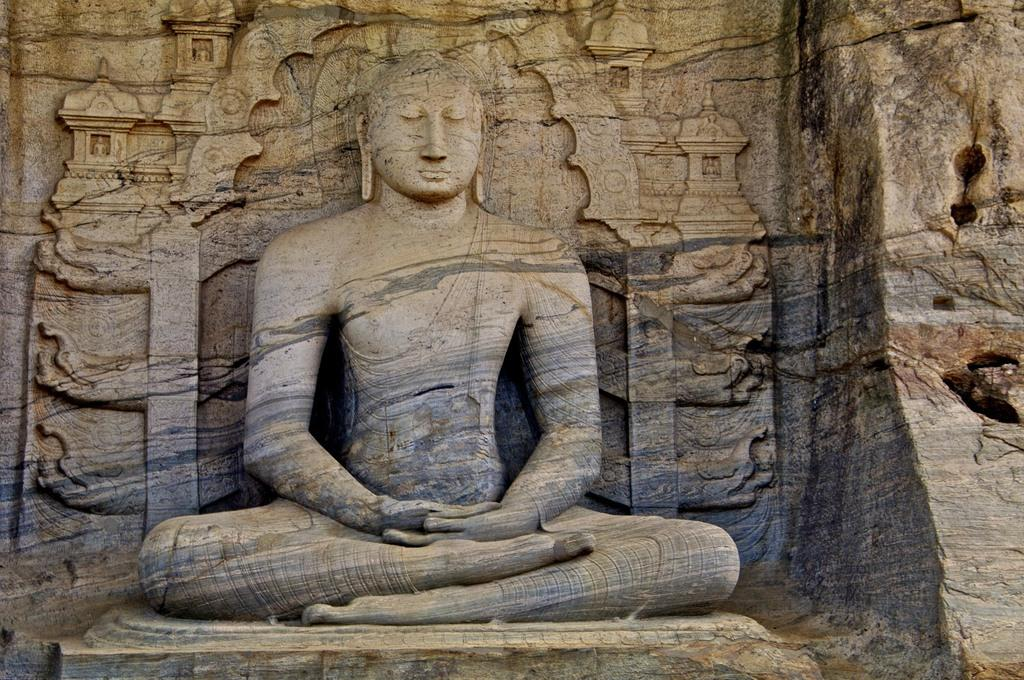What is the main subject of the image? There is a sculpture in the image. Where is the sculpture located? The sculpture is on a rock. Can you tell me which animals are present in the zoo depicted in the image? There is no zoo present in the image; it features a sculpture on a rock. What level of expertise is required to create the sculpture in the image? The level of expertise required to create the sculpture cannot be determined from the image alone. 